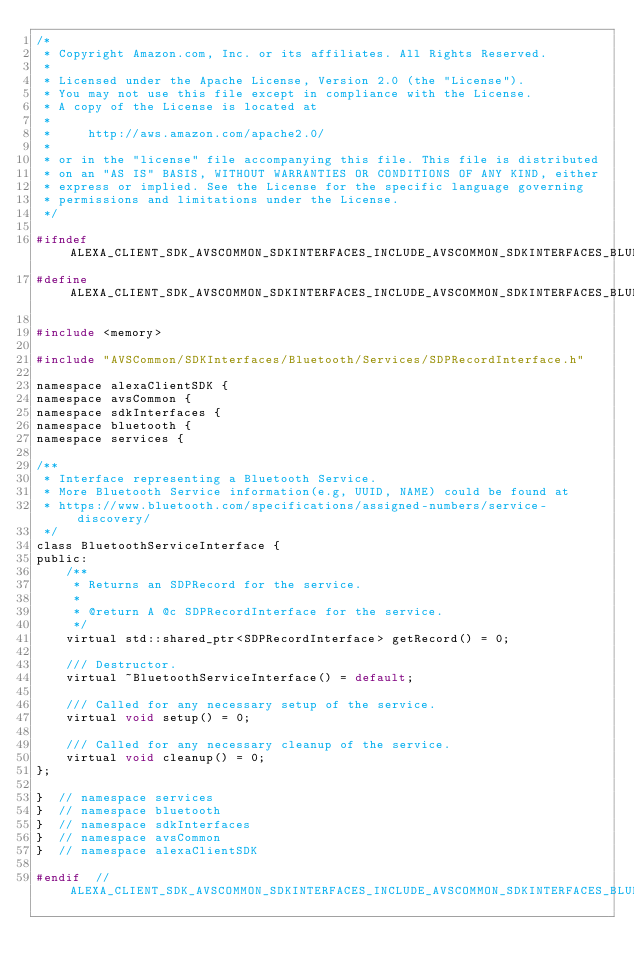<code> <loc_0><loc_0><loc_500><loc_500><_C_>/*
 * Copyright Amazon.com, Inc. or its affiliates. All Rights Reserved.
 *
 * Licensed under the Apache License, Version 2.0 (the "License").
 * You may not use this file except in compliance with the License.
 * A copy of the License is located at
 *
 *     http://aws.amazon.com/apache2.0/
 *
 * or in the "license" file accompanying this file. This file is distributed
 * on an "AS IS" BASIS, WITHOUT WARRANTIES OR CONDITIONS OF ANY KIND, either
 * express or implied. See the License for the specific language governing
 * permissions and limitations under the License.
 */

#ifndef ALEXA_CLIENT_SDK_AVSCOMMON_SDKINTERFACES_INCLUDE_AVSCOMMON_SDKINTERFACES_BLUETOOTH_SERVICES_BLUETOOTHSERVICEINTERFACE_H_
#define ALEXA_CLIENT_SDK_AVSCOMMON_SDKINTERFACES_INCLUDE_AVSCOMMON_SDKINTERFACES_BLUETOOTH_SERVICES_BLUETOOTHSERVICEINTERFACE_H_

#include <memory>

#include "AVSCommon/SDKInterfaces/Bluetooth/Services/SDPRecordInterface.h"

namespace alexaClientSDK {
namespace avsCommon {
namespace sdkInterfaces {
namespace bluetooth {
namespace services {

/**
 * Interface representing a Bluetooth Service.
 * More Bluetooth Service information(e.g, UUID, NAME) could be found at
 * https://www.bluetooth.com/specifications/assigned-numbers/service-discovery/
 */
class BluetoothServiceInterface {
public:
    /**
     * Returns an SDPRecord for the service.
     *
     * @return A @c SDPRecordInterface for the service.
     */
    virtual std::shared_ptr<SDPRecordInterface> getRecord() = 0;

    /// Destructor.
    virtual ~BluetoothServiceInterface() = default;

    /// Called for any necessary setup of the service.
    virtual void setup() = 0;

    /// Called for any necessary cleanup of the service.
    virtual void cleanup() = 0;
};

}  // namespace services
}  // namespace bluetooth
}  // namespace sdkInterfaces
}  // namespace avsCommon
}  // namespace alexaClientSDK

#endif  // ALEXA_CLIENT_SDK_AVSCOMMON_SDKINTERFACES_INCLUDE_AVSCOMMON_SDKINTERFACES_BLUETOOTH_SERVICES_BLUETOOTHSERVICEINTERFACE_H_
</code> 